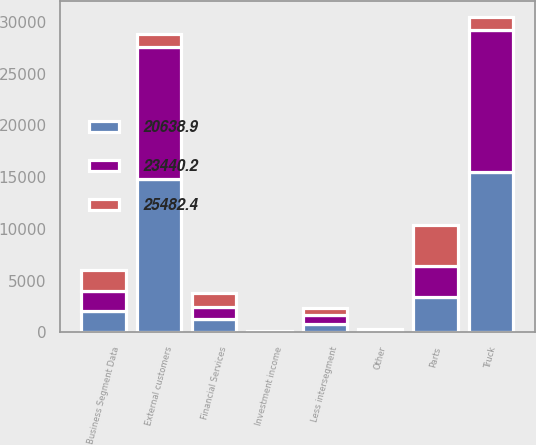Convert chart to OTSL. <chart><loc_0><loc_0><loc_500><loc_500><stacked_bar_chart><ecel><fcel>Business Segment Data<fcel>Truck<fcel>Less intersegment<fcel>External customers<fcel>Parts<fcel>Other<fcel>Financial Services<fcel>Investment income<nl><fcel>25482.4<fcel>2018<fcel>1313<fcel>676.1<fcel>1313<fcel>3896.2<fcel>112.7<fcel>1357.1<fcel>60.9<nl><fcel>20638.9<fcel>2017<fcel>15543.7<fcel>768.9<fcel>14774.8<fcel>3380.2<fcel>85.7<fcel>1268.9<fcel>35.3<nl><fcel>23440.2<fcel>2016<fcel>13652.7<fcel>885.4<fcel>12767.3<fcel>3052.9<fcel>73.6<fcel>1186.7<fcel>27.6<nl></chart> 